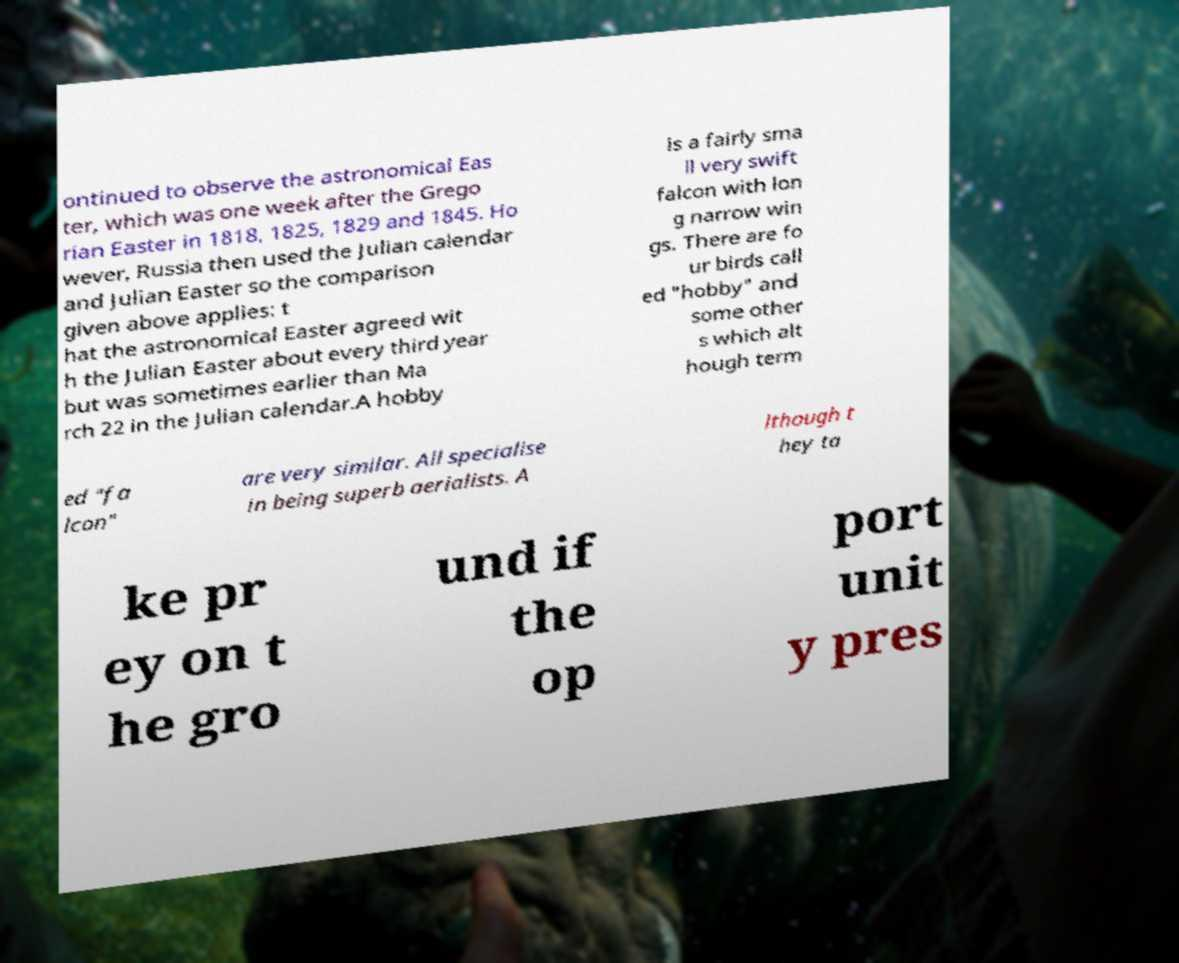I need the written content from this picture converted into text. Can you do that? ontinued to observe the astronomical Eas ter, which was one week after the Grego rian Easter in 1818, 1825, 1829 and 1845. Ho wever, Russia then used the Julian calendar and Julian Easter so the comparison given above applies: t hat the astronomical Easter agreed wit h the Julian Easter about every third year but was sometimes earlier than Ma rch 22 in the Julian calendar.A hobby is a fairly sma ll very swift falcon with lon g narrow win gs. There are fo ur birds call ed "hobby" and some other s which alt hough term ed "fa lcon" are very similar. All specialise in being superb aerialists. A lthough t hey ta ke pr ey on t he gro und if the op port unit y pres 